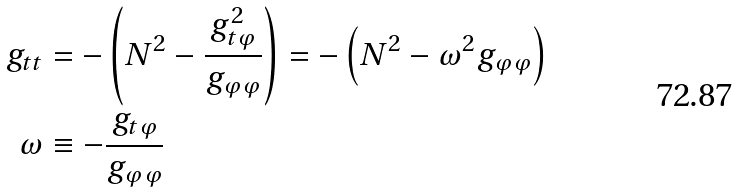<formula> <loc_0><loc_0><loc_500><loc_500>g _ { t t } & = - \left ( N ^ { 2 } - \frac { g _ { t \varphi } ^ { 2 } } { g _ { \varphi \varphi } } \right ) = - \left ( N ^ { 2 } - \omega ^ { 2 } g _ { \varphi \varphi } \right ) \\ \omega & \equiv - \frac { g _ { t \varphi } } { g _ { \varphi \varphi } }</formula> 